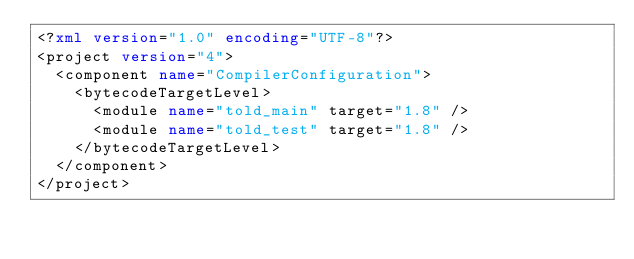<code> <loc_0><loc_0><loc_500><loc_500><_XML_><?xml version="1.0" encoding="UTF-8"?>
<project version="4">
  <component name="CompilerConfiguration">
    <bytecodeTargetLevel>
      <module name="told_main" target="1.8" />
      <module name="told_test" target="1.8" />
    </bytecodeTargetLevel>
  </component>
</project></code> 